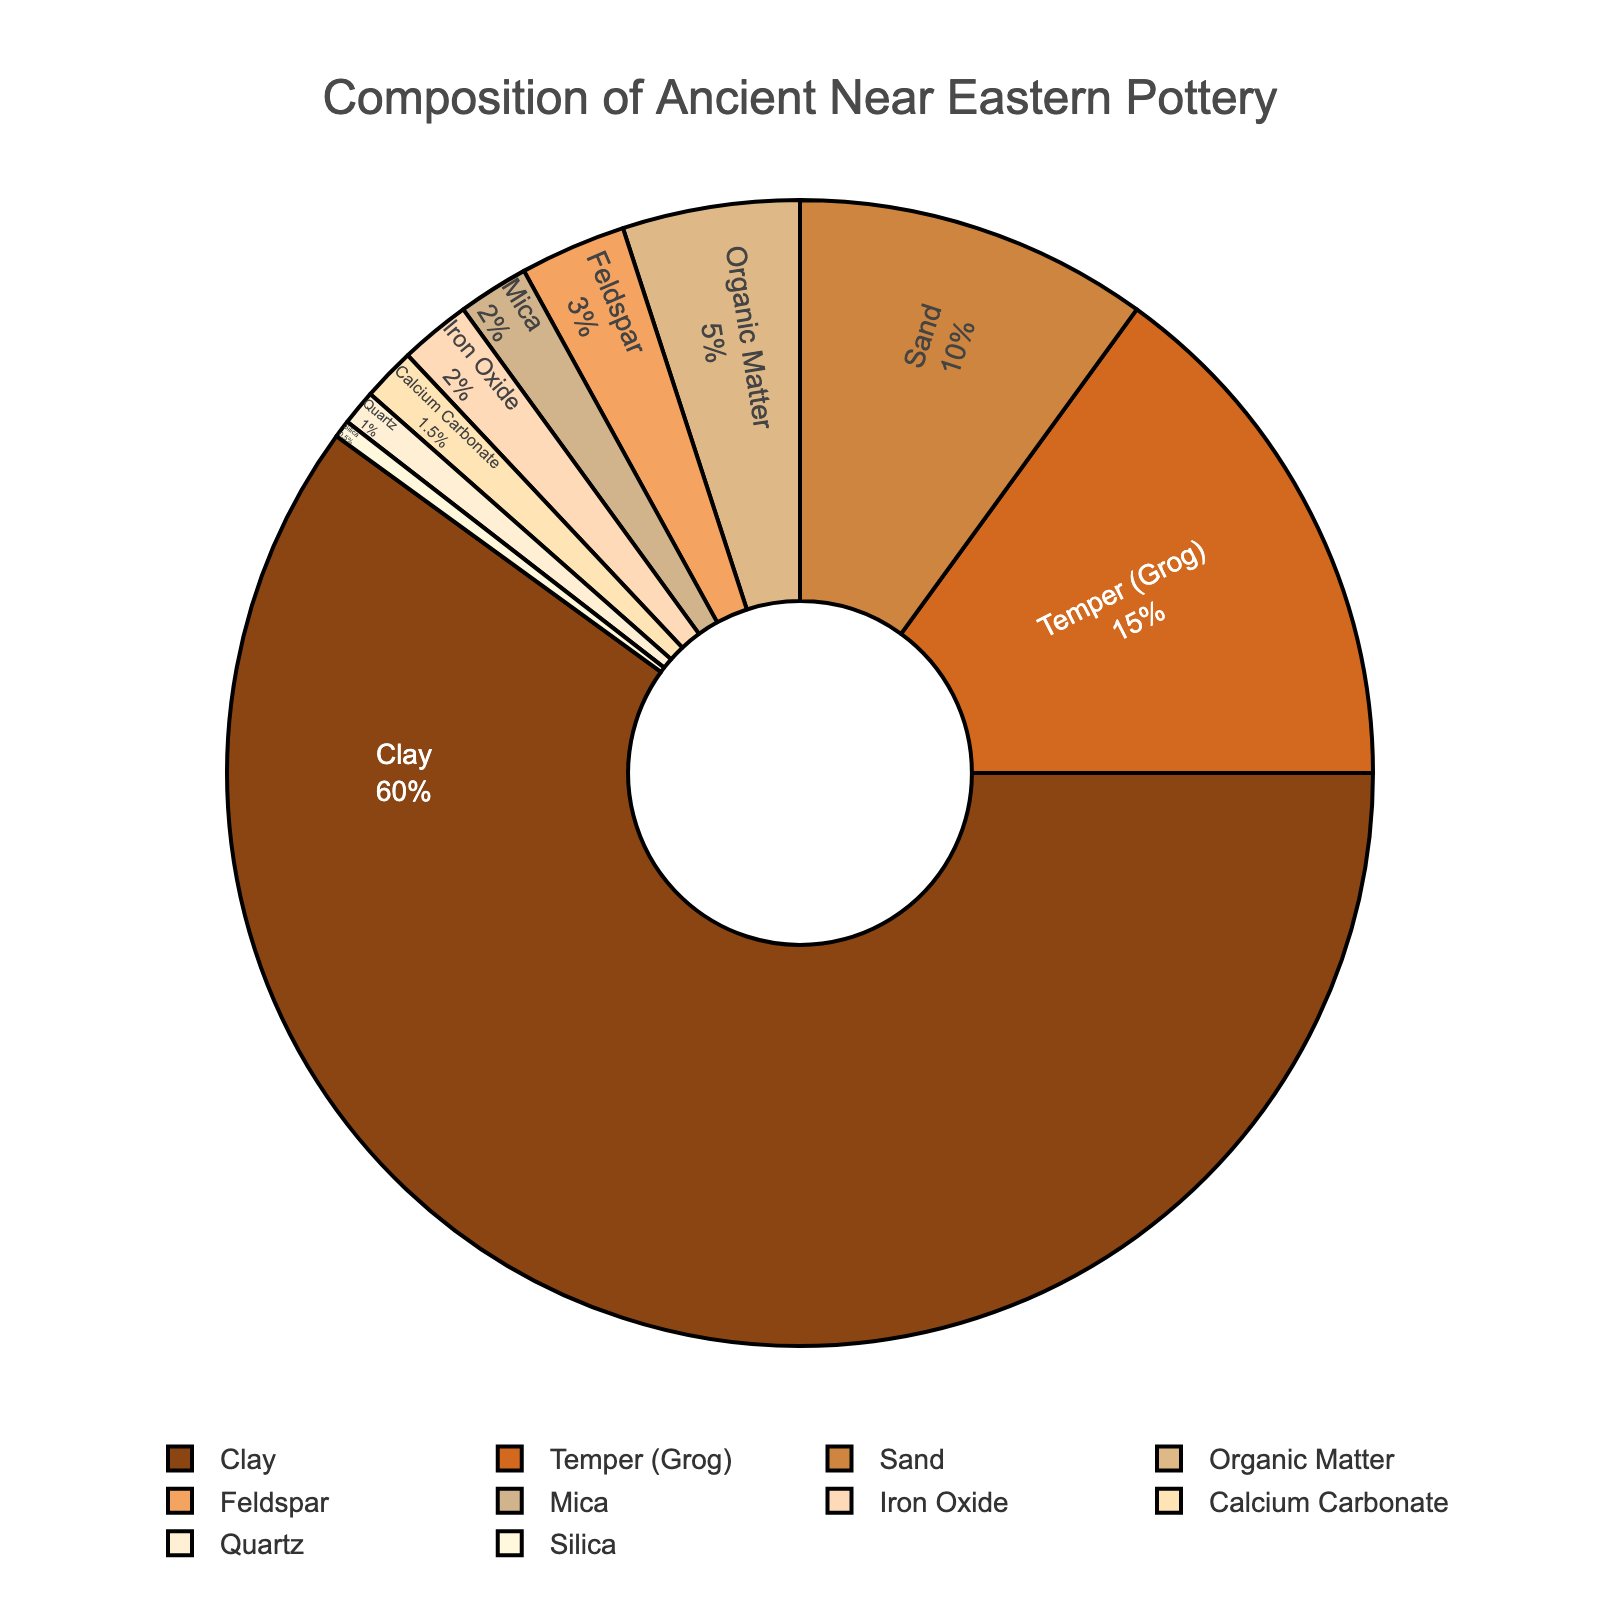Which two materials combined have the highest percentage in the composition? To determine the highest combined percentage, look for the two materials with the highest individual percentages in the pie chart. Here, Clay has 60% and Temper (Grog) has 15%. Adding these up gives: 60% + 15% = 75%
Answer: Clay and Temper (Grog) Which material has the smallest contribution to the pottery composition? The smallest section of the pie chart represents the material with the lowest percentage. In this case, it is Silica, which has a percentage of 0.5%
Answer: Silica What is the difference in percentage between the material with the highest percentage and the material with the second highest percentage? Find the highest percentage (Clay at 60%) and the second highest percentage (Temper (Grog) at 15%). Subtract the second highest from the highest: 60% - 15% = 45%
Answer: 45% Are there more inorganic or organic materials in the composition? Identify organic and inorganic materials and their respective segments in the pie chart. Organic Matter is the only organic material with 5%. The rest are inorganic. Sum up the percentages of inorganic materials and compare: (60+15+10+3+2+2+1.5+1+0.5)=95%. 95% (inorganic) > 5% (organic)
Answer: Inorganic materials Which material's percentage is closest to the median percentage value of all materials listed? List the percentage values in ascending order: 0.5, 1, 1.5, 2, 2, 3, 5, 10, 15, 60. The median lies between the 5th and 6th values: (2+3)/2 = 2.5. Feldspar (3%) is the closest to 2.5%
Answer: Feldspar What is the sum of percentages for materials having less than 2% contribution each? Identify materials with less than 2% and sum their percentages: Mica (2%), Iron Oxide (2%), Calcium Carbonate (1.5%), Quartz (1%), Silica (0.5%). Since Mica and Iron Oxide are exactly 2%, they are excluded. Thus: 1.5 + 1 + 0.5 = 3%
Answer: 3% Compare the proportion of Clay to Sand. Which is greater and by how much? Locate percentages for Clay (60%) and Sand (10%). Subtract the smaller percentage from the larger: 60% - 10% = 50%. Clay is greater by 50%
Answer: Clay is greater by 50% What fraction of the total composition is accounted for by organic matter? Organic Matter has a percentage of 5%. To find the fraction, express 5% as a fraction of 100%: 5/100 = 1/20
Answer: 1/20 If the percentage for Quartz and Silica were combined, how would it compare to the percentage for Feldspar? Summing Quartz (1%) and Silica (0.5%) gives 1% + 0.5% = 1.5%. Comparing to Feldspar (3%), Feldspar is greater: 3% - 1.5% = 1.5%
Answer: Feldspar is 1.5% greater What is the cumulative percentage of the three least present materials? Identify the three materials with the lowest percentages: Silica (0.5%), Quartz (1%), Calcium Carbonate (1.5%). Sum these up: 0.5% + 1% + 1.5% = 3%
Answer: 3% 